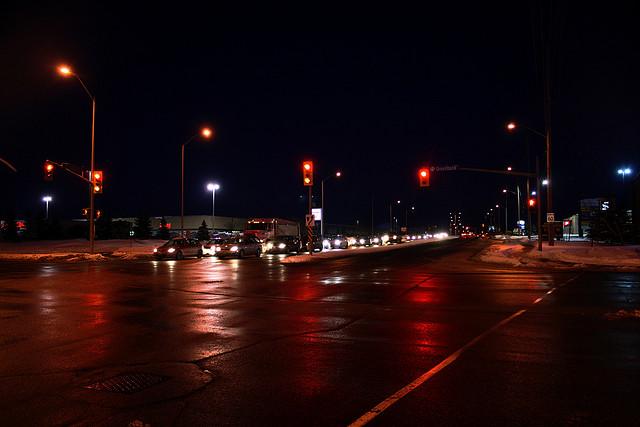What color are the traffic lights?
Concise answer only. Red. What kind of street intersection is pictured?
Give a very brief answer. 4 way. Is this a busy street?
Write a very short answer. Yes. Is the street busy?
Quick response, please. No. What should traffic do?
Be succinct. Stop. Is it daytime?
Write a very short answer. No. 